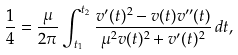<formula> <loc_0><loc_0><loc_500><loc_500>\frac { 1 } { 4 } = \frac { \mu } { 2 \pi } \int _ { t _ { 1 } } ^ { t _ { 2 } } \frac { v ^ { \prime } ( t ) ^ { 2 } - v ( t ) v ^ { \prime \prime } ( t ) } { \mu ^ { 2 } v ( t ) ^ { 2 } + v ^ { \prime } ( t ) ^ { 2 } } \, d t ,</formula> 